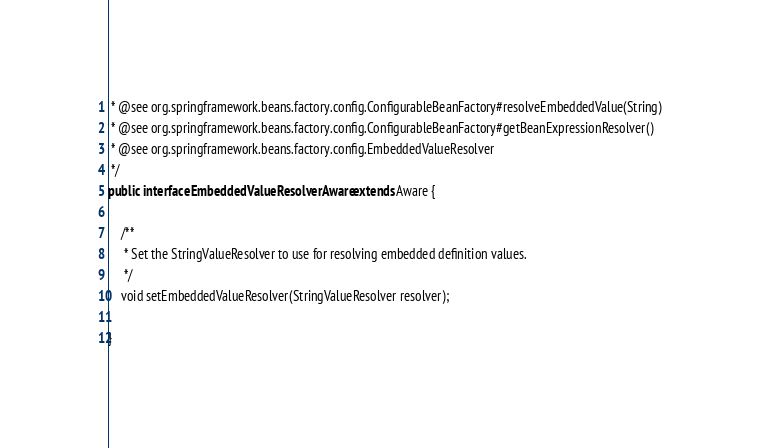<code> <loc_0><loc_0><loc_500><loc_500><_Java_> * @see org.springframework.beans.factory.config.ConfigurableBeanFactory#resolveEmbeddedValue(String)
 * @see org.springframework.beans.factory.config.ConfigurableBeanFactory#getBeanExpressionResolver()
 * @see org.springframework.beans.factory.config.EmbeddedValueResolver
 */
public interface EmbeddedValueResolverAware extends Aware {

	/**
	 * Set the StringValueResolver to use for resolving embedded definition values.
	 */
	void setEmbeddedValueResolver(StringValueResolver resolver);

}
</code> 